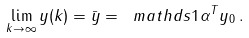<formula> <loc_0><loc_0><loc_500><loc_500>\lim _ { k \rightarrow \infty } y ( k ) = \bar { y } = \ m a t h d s { 1 } \alpha ^ { T } y _ { 0 } \, .</formula> 